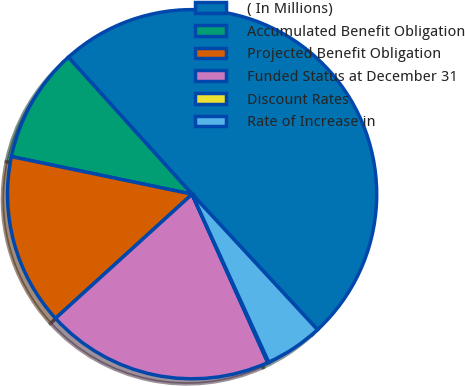Convert chart. <chart><loc_0><loc_0><loc_500><loc_500><pie_chart><fcel>( In Millions)<fcel>Accumulated Benefit Obligation<fcel>Projected Benefit Obligation<fcel>Funded Status at December 31<fcel>Discount Rates<fcel>Rate of Increase in<nl><fcel>49.81%<fcel>10.04%<fcel>15.01%<fcel>19.98%<fcel>0.09%<fcel>5.07%<nl></chart> 